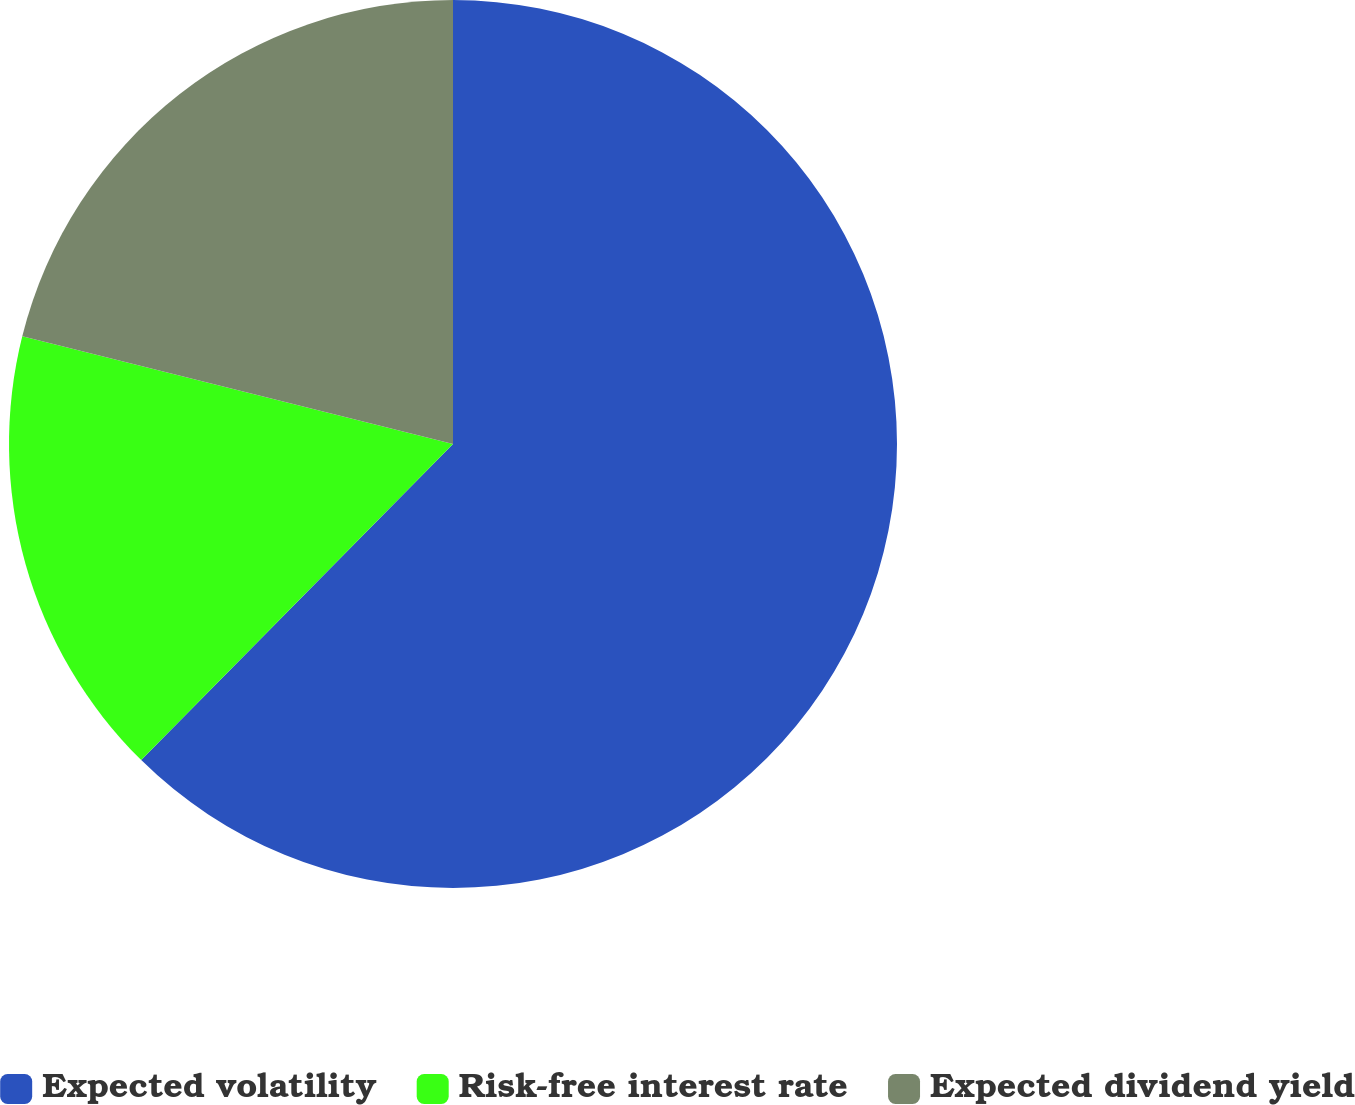Convert chart. <chart><loc_0><loc_0><loc_500><loc_500><pie_chart><fcel>Expected volatility<fcel>Risk-free interest rate<fcel>Expected dividend yield<nl><fcel>62.39%<fcel>16.51%<fcel>21.1%<nl></chart> 